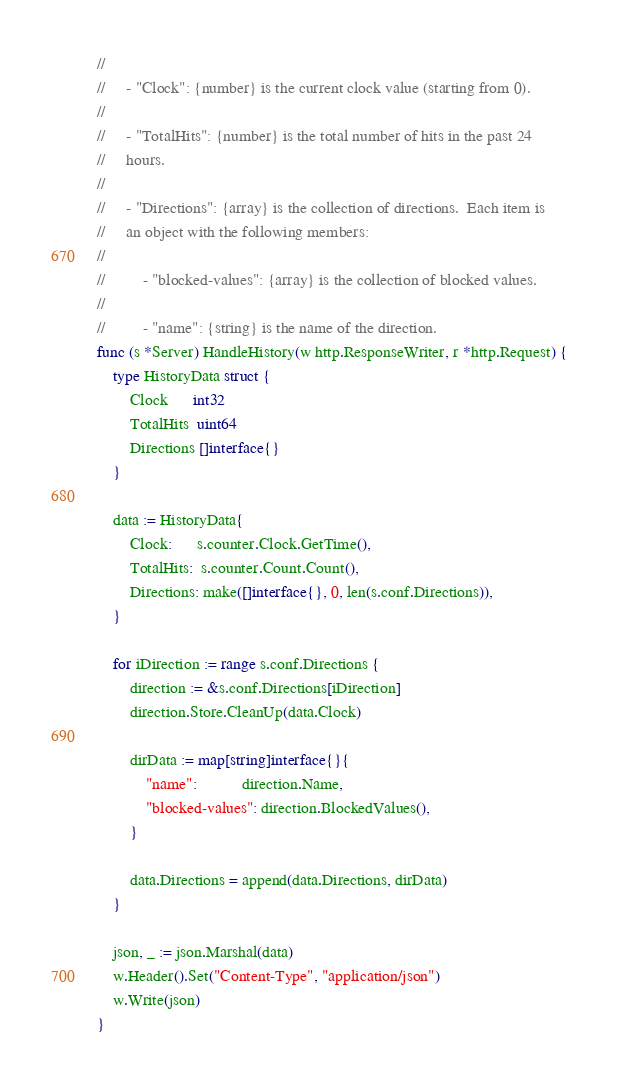<code> <loc_0><loc_0><loc_500><loc_500><_Go_>//
//     - "Clock": {number} is the current clock value (starting from 0).
//
//     - "TotalHits": {number} is the total number of hits in the past 24
//     hours.
//
//     - "Directions": {array} is the collection of directions.  Each item is
//     an object with the following members:
//
//         - "blocked-values": {array} is the collection of blocked values.
//
//         - "name": {string} is the name of the direction.
func (s *Server) HandleHistory(w http.ResponseWriter, r *http.Request) {
	type HistoryData struct {
		Clock      int32
		TotalHits  uint64
		Directions []interface{}
	}

	data := HistoryData{
		Clock:      s.counter.Clock.GetTime(),
		TotalHits:  s.counter.Count.Count(),
		Directions: make([]interface{}, 0, len(s.conf.Directions)),
	}

	for iDirection := range s.conf.Directions {
		direction := &s.conf.Directions[iDirection]
		direction.Store.CleanUp(data.Clock)

		dirData := map[string]interface{}{
			"name":           direction.Name,
			"blocked-values": direction.BlockedValues(),
		}

		data.Directions = append(data.Directions, dirData)
	}

	json, _ := json.Marshal(data)
	w.Header().Set("Content-Type", "application/json")
	w.Write(json)
}
</code> 